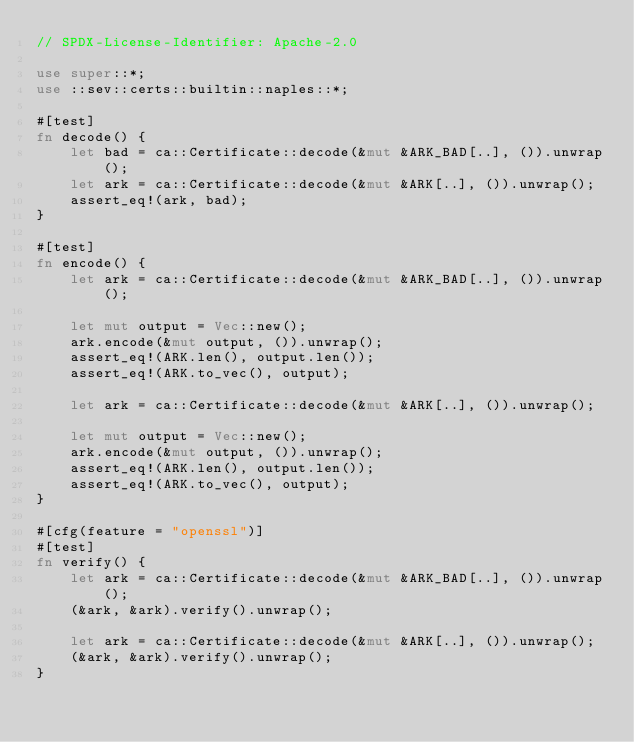<code> <loc_0><loc_0><loc_500><loc_500><_Rust_>// SPDX-License-Identifier: Apache-2.0

use super::*;
use ::sev::certs::builtin::naples::*;

#[test]
fn decode() {
    let bad = ca::Certificate::decode(&mut &ARK_BAD[..], ()).unwrap();
    let ark = ca::Certificate::decode(&mut &ARK[..], ()).unwrap();
    assert_eq!(ark, bad);
}

#[test]
fn encode() {
    let ark = ca::Certificate::decode(&mut &ARK_BAD[..], ()).unwrap();

    let mut output = Vec::new();
    ark.encode(&mut output, ()).unwrap();
    assert_eq!(ARK.len(), output.len());
    assert_eq!(ARK.to_vec(), output);

    let ark = ca::Certificate::decode(&mut &ARK[..], ()).unwrap();

    let mut output = Vec::new();
    ark.encode(&mut output, ()).unwrap();
    assert_eq!(ARK.len(), output.len());
    assert_eq!(ARK.to_vec(), output);
}

#[cfg(feature = "openssl")]
#[test]
fn verify() {
    let ark = ca::Certificate::decode(&mut &ARK_BAD[..], ()).unwrap();
    (&ark, &ark).verify().unwrap();

    let ark = ca::Certificate::decode(&mut &ARK[..], ()).unwrap();
    (&ark, &ark).verify().unwrap();
}
</code> 